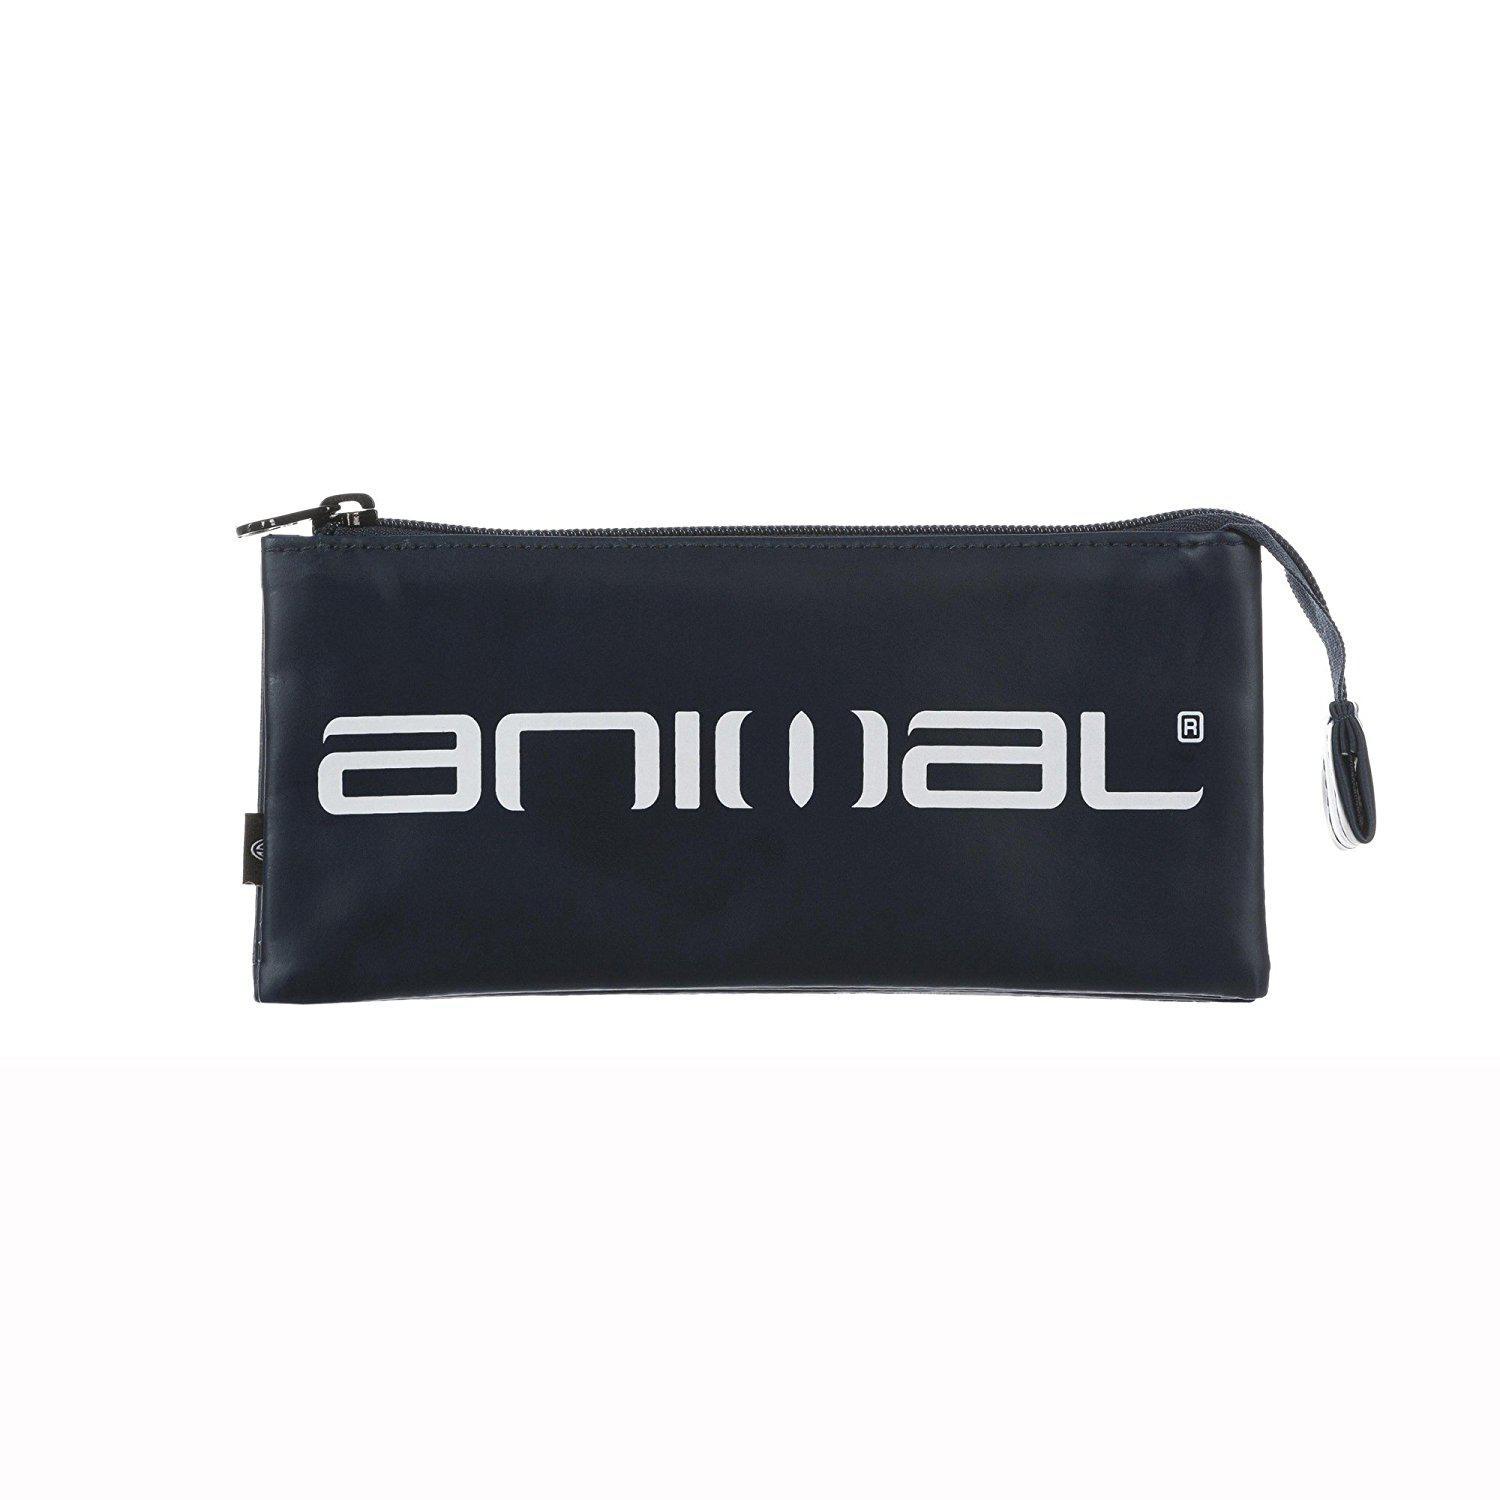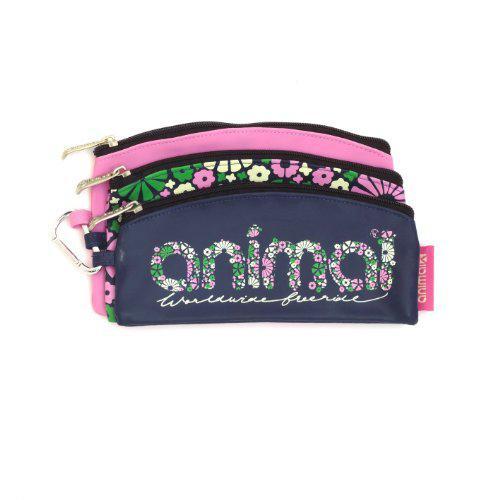The first image is the image on the left, the second image is the image on the right. Considering the images on both sides, is "Both pouches have the word """"animal"""" on them." valid? Answer yes or no. Yes. 